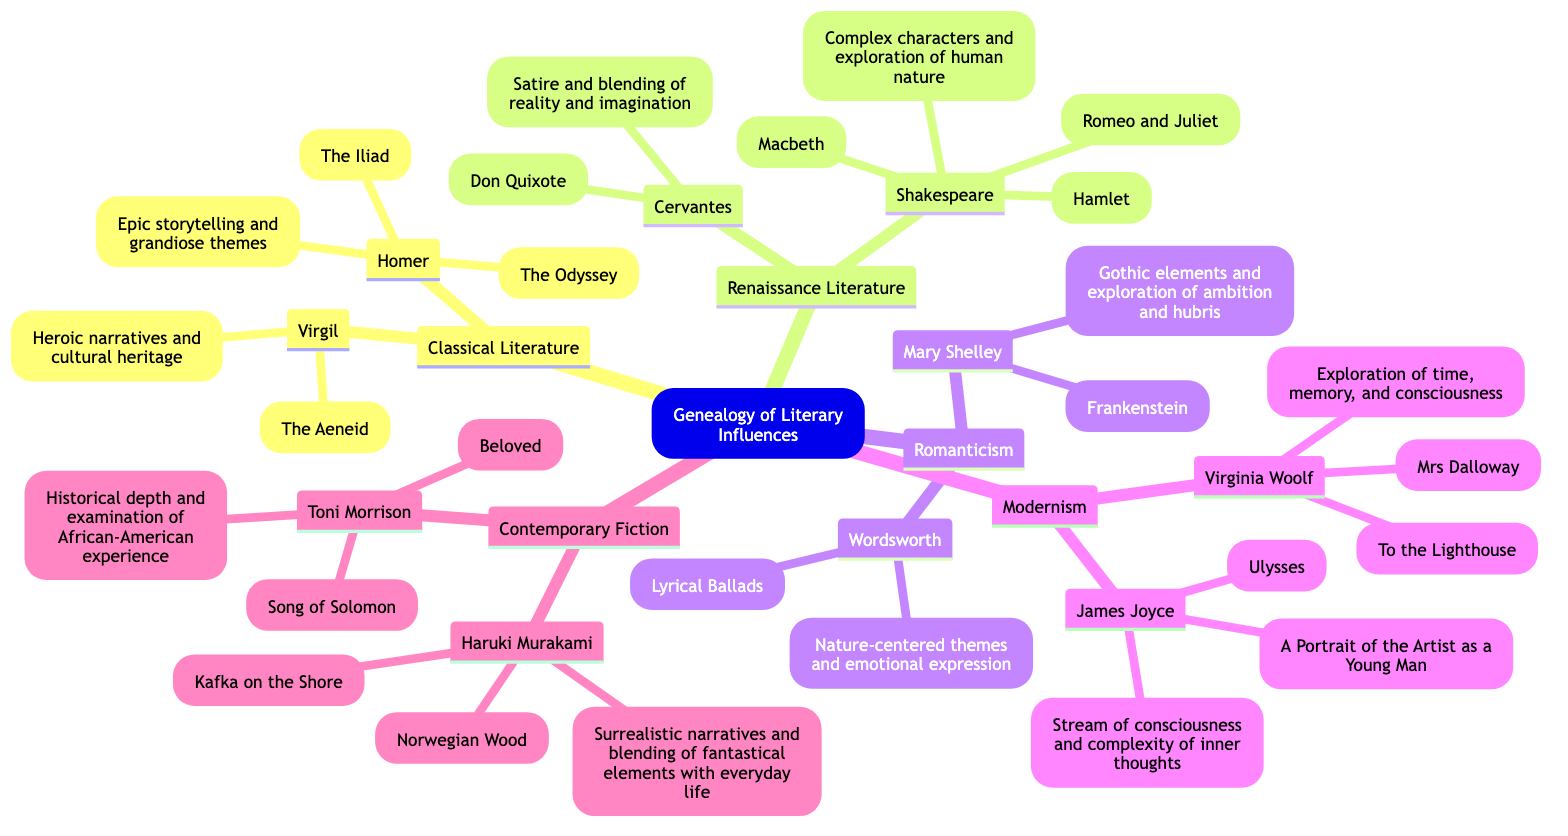What are two works by Homer? The diagram lists "The Iliad" and "The Odyssey" under the author Homer in the Classical Literature branch.
Answer: The Iliad, The Odyssey Who wrote "Frankenstein"? In the Romanticism branch, Mary Shelley is mentioned as the author of "Frankenstein."
Answer: Mary Shelley What influence is associated with Toni Morrison? Looking at the Contemporary Fiction branch, the influence noted for Toni Morrison relates to "Historical depth and examination of African-American experience."
Answer: Historical depth and examination of African-American experience How many authors are listed in the Modernism branch? The Modernism branch contains two authors: James Joyce and Virginia Woolf. Therefore, the total number of authors is 2.
Answer: 2 Which literary movement focuses on the complex characters and exploration of human nature? The Renaissance Literature branch indicates that William Shakespeare's works "Hamlet," "Macbeth," and "Romeo and Juliet" explore complex characters and human nature.
Answer: Renaissance Literature What genre does "Kafka on the Shore" belong to? The diagram specifies that "Kafka on the Shore," authored by Haruki Murakami, is part of the Contemporary Fiction branch.
Answer: Contemporary Fiction Which author is associated with the influence of "Gothic elements and exploration of ambition and hubris"? The Romanticism branch shows that this influence is linked to Mary Shelley through her work "Frankenstein."
Answer: Mary Shelley How many works did Virgil write, according to the diagram? The diagram lists one work by Virgil, which is "The Aeneid," denoting he authored one work in this context.
Answer: 1 What is the common theme tied to Nature in the Romanticism branch? In the Romanticism branch, William Wordsworth is associated with "Nature-centered themes" through his work "Lyrical Ballads."
Answer: Nature-centered themes 